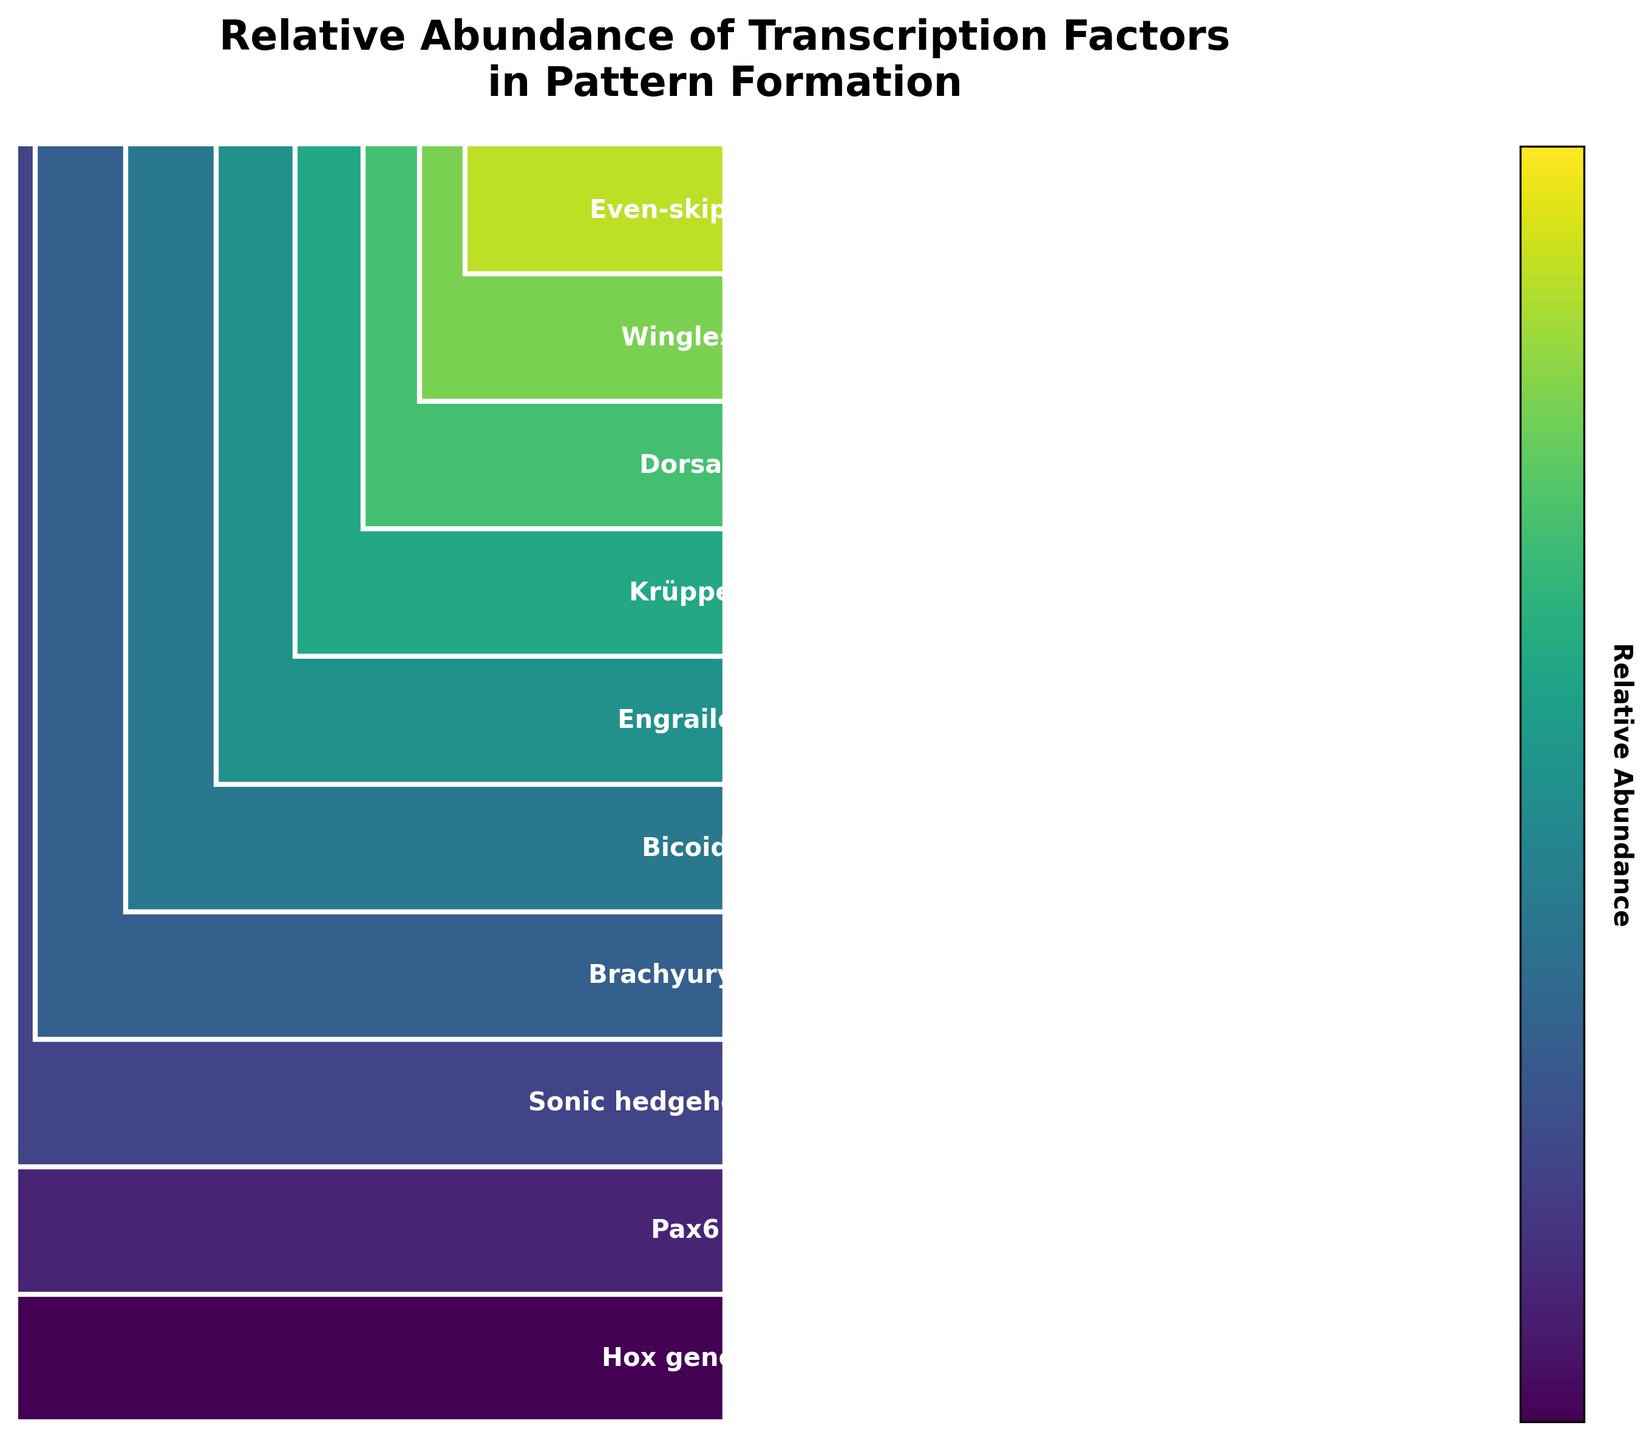Which transcription factor has the highest relative abundance? Hox genes have a relative abundance of 100%, which is the highest among the transcription factors listed.
Answer: Hox genes What is the title of the figure? The title of the figure is displayed at the top, stating the main idea of the plot.
Answer: Relative Abundance of Transcription Factors in Pattern Formation How many transcription factors are represented in the figure? By counting the unique labels that annotate each segment of the funnel chart, there are 10 transcription factors shown.
Answer: 10 Which two transcription factors have the closest relative abundance values? Compare the values and find the smallest difference between the two, which is 7 (Krüppel 38% and Dorsal 32%).
Answer: Krüppel and Dorsal What is the difference in relative abundance between the top and bottom transcription factors? The top transcription factor (Hox genes) has a relative abundance of 100%, and the bottom one (Even-skipped) has 23%, resulting in a difference of 77%.
Answer: 77% Which transcription factor has about half the relative abundance of Hox genes? Hox genes have 100%, and approximately half of that would be 50%. Bicoid, with 53%, is the closest value to half of 100%.
Answer: Bicoid What is the sum of the relative abundances of Pax6, Sonic hedgehog (Shh), and Brachyury (T)? Adding the relative abundances: 85 (Pax6) + 72 (Shh) + 61 (Brachyury (T)) = 218%.
Answer: 218% Which transcription factor shows a relative abundance around one-fourth of Hox genes? One-fourth of 100% is 25%, and Wingless has a relative abundance of 27%, which is closest to one-fourth.
Answer: Wingless Is Krüppel more or less abundant than Engrailed? Comparing their relative abundances, Krüppel (38%) is less abundant than Engrailed (45%).
Answer: Less abundant What is the average relative abundance of the transcription factors listed? Sum all relative abundances and divide by the number of transcription factors: (100 + 85 + 72 + 61 + 53 + 45 + 38 + 32 + 27 + 23) / 10 = 53.6%.
Answer: 53.6% 